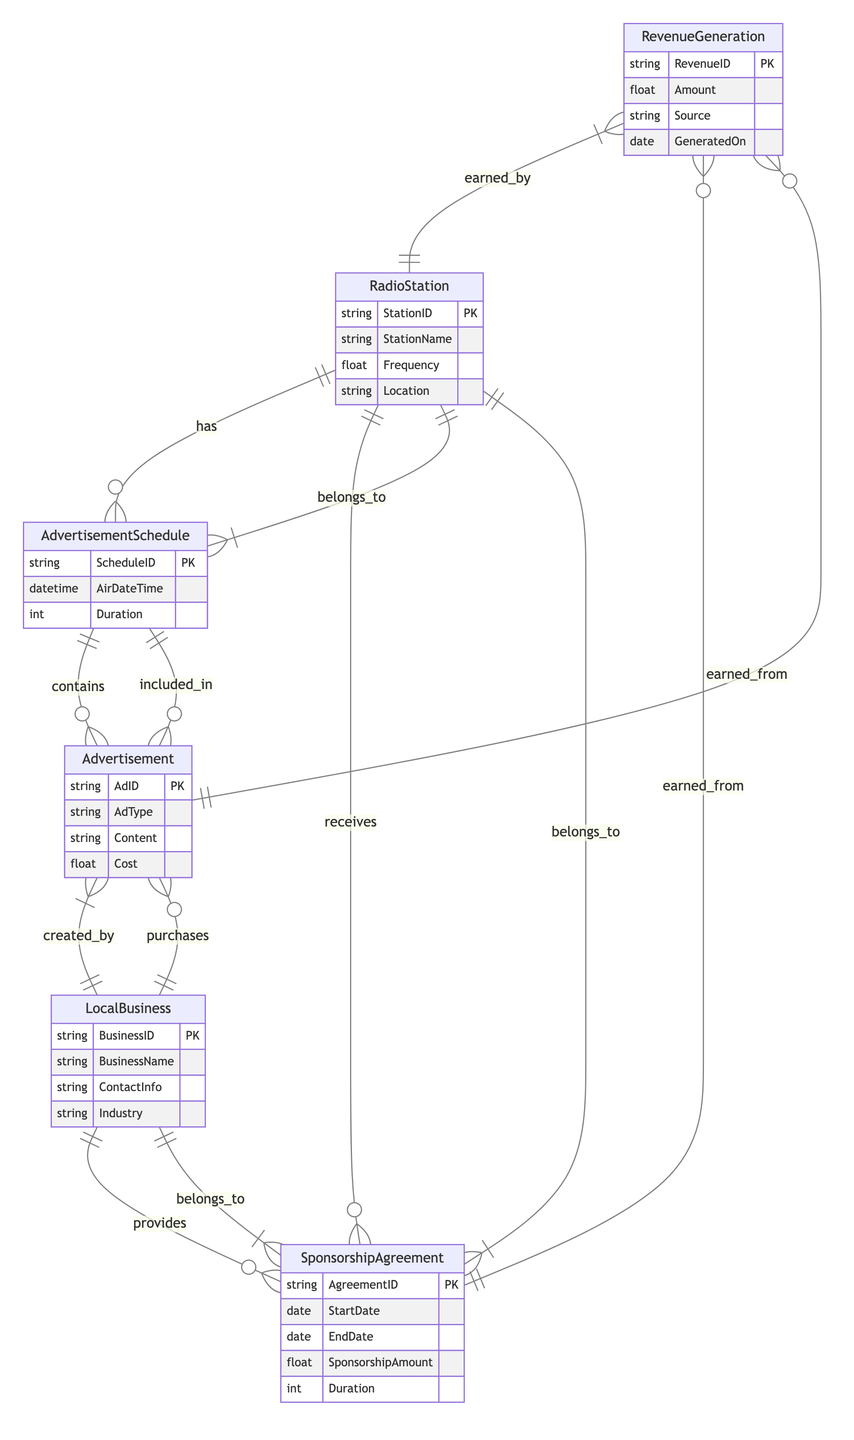What's the primary entity representing the radio station? The primary entity representing the radio station is labeled "RadioStation," which holds information about the station's ID, name, frequency, and location.
Answer: RadioStation How many attributes does the LocalBusiness entity have? The LocalBusiness entity comprises four attributes: BusinessID, BusinessName, ContactInfo, and Industry.
Answer: Four What type of relationship exists between SponsorshipAgreement and LocalBusiness? The relationship between SponsorshipAgreement and LocalBusiness is classified as "belongs_to," indicating that each agreement is associated with a specific local business.
Answer: belongs_to How many entities are depicted in the diagram? The diagram includes six entities: RadioStation, LocalBusiness, SponsorshipAgreement, Advertisement, AdvertisementSchedule, and RevenueGeneration. Counting these gives a total of six.
Answer: Six Which entity generates revenue from advertisements? The RevenueGeneration entity generates revenue from advertisements, as indicated by the relationship "earned_from" connecting it to the Advertisement entity.
Answer: RevenueGeneration What is the relationship type between AdvertisementSchedule and RadioStation? The relationship type between AdvertisementSchedule and RadioStation is categorized as "belongs_to," which indicates that each advertisement schedule is associated with a specific radio station.
Answer: belongs_to Which entity provides sponsorship agreements? The LocalBusiness entity is responsible for providing sponsorship agreements, as indicated by the relationship type "provides" linking it to the SponsorshipAgreement entity.
Answer: LocalBusiness What is the maximum number of advertisements that can be included in an AdvertisementSchedule? The diagram does not specify a maximum number; however, it indicates that the AdvertisementSchedule can contain multiple advertisements, as suggested by the relationship type "contains."
Answer: Not specified What does the RevenueGeneration entity track? The RevenueGeneration entity tracks various pieces of financial information, such as the total amount of revenue, the source of that revenue, and the date it was generated.
Answer: Financial information Which entity is linked to advertisement purchases? The LocalBusiness entity is linked to advertisement purchases, as shown by the relationship type "purchases" connecting it to the Advertisement entity.
Answer: LocalBusiness 